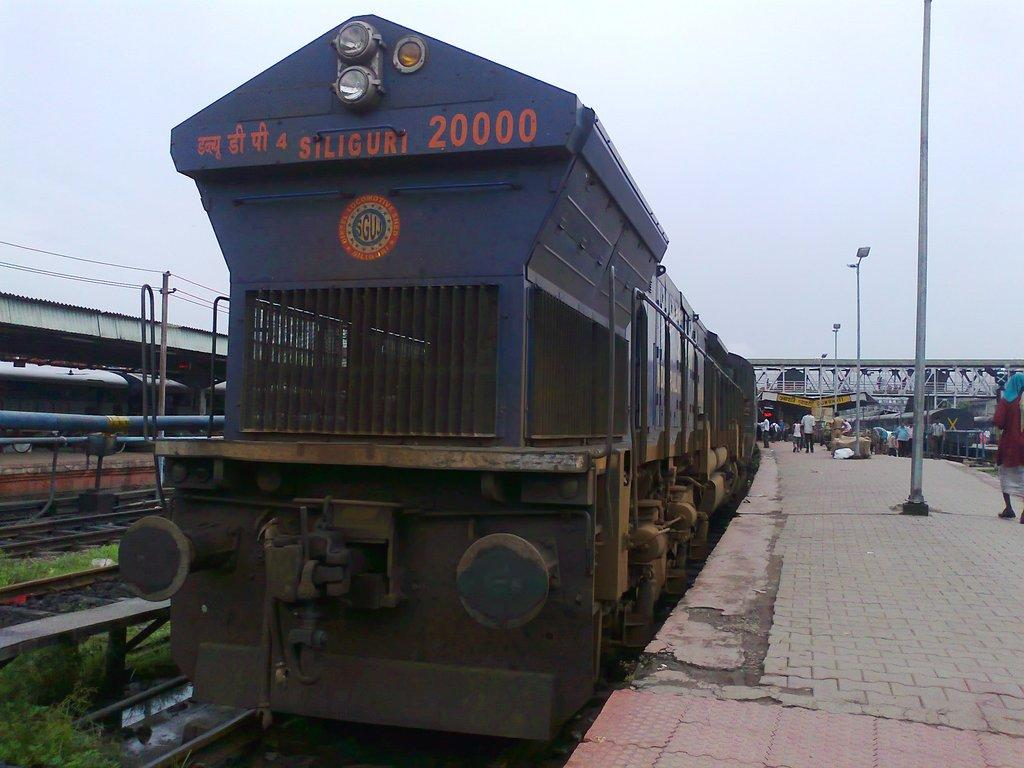What is the main subject of the image? The main subject of the image is a train. Where is the train located in the image? The train is on a railway track. What can be seen on the right side of the image? There is a platform on the right side of the image. Are there any people in the image? Yes, there are people on the platform. What type of cakes are being served on the train in the image? There is no mention of cakes or any food being served in the image; it only shows a train on a railway track and a platform with people. 